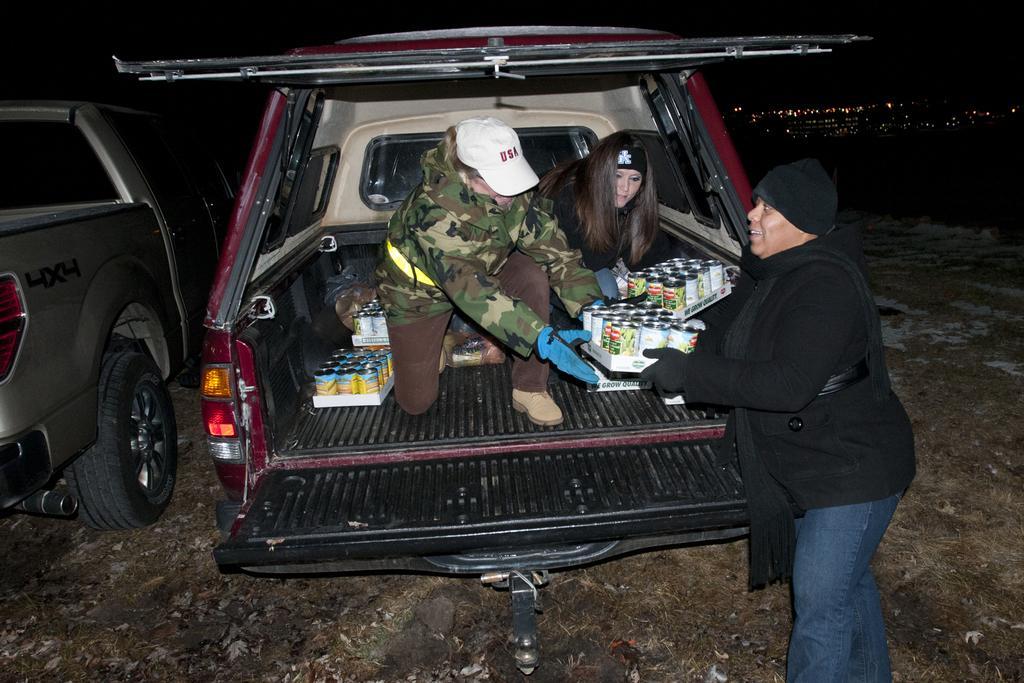How would you summarize this image in a sentence or two? In this picture there is a car at the center of the image, there are two girls in the car and there are shifting the stock from the car and giving it to the lady who is standing outside the car and it is a night time. 